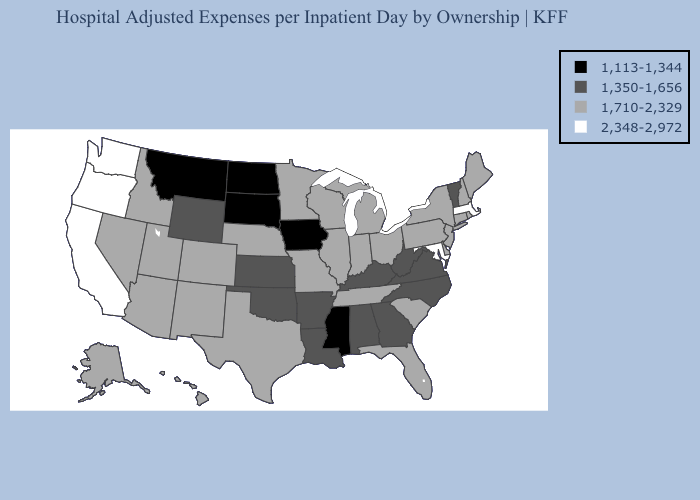Name the states that have a value in the range 1,710-2,329?
Concise answer only. Alaska, Arizona, Colorado, Connecticut, Delaware, Florida, Hawaii, Idaho, Illinois, Indiana, Maine, Michigan, Minnesota, Missouri, Nebraska, Nevada, New Hampshire, New Jersey, New Mexico, New York, Ohio, Pennsylvania, Rhode Island, South Carolina, Tennessee, Texas, Utah, Wisconsin. Among the states that border Texas , does Louisiana have the highest value?
Give a very brief answer. No. Does the first symbol in the legend represent the smallest category?
Keep it brief. Yes. Does Montana have the same value as South Dakota?
Answer briefly. Yes. Does Washington have the highest value in the USA?
Answer briefly. Yes. Does the map have missing data?
Concise answer only. No. What is the highest value in states that border New Hampshire?
Concise answer only. 2,348-2,972. Name the states that have a value in the range 1,350-1,656?
Quick response, please. Alabama, Arkansas, Georgia, Kansas, Kentucky, Louisiana, North Carolina, Oklahoma, Vermont, Virginia, West Virginia, Wyoming. Name the states that have a value in the range 1,350-1,656?
Keep it brief. Alabama, Arkansas, Georgia, Kansas, Kentucky, Louisiana, North Carolina, Oklahoma, Vermont, Virginia, West Virginia, Wyoming. Among the states that border Pennsylvania , which have the highest value?
Keep it brief. Maryland. Does South Carolina have a lower value than Delaware?
Short answer required. No. What is the value of Louisiana?
Quick response, please. 1,350-1,656. What is the lowest value in states that border Montana?
Concise answer only. 1,113-1,344. Does North Carolina have the lowest value in the USA?
Be succinct. No. What is the value of Louisiana?
Answer briefly. 1,350-1,656. 